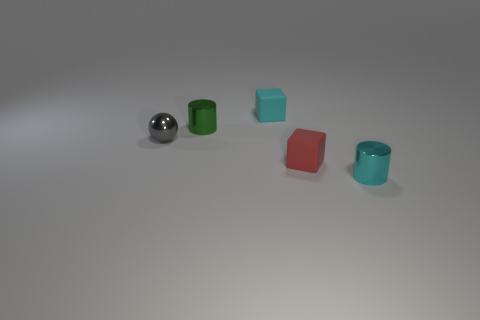How many tiny red things have the same shape as the cyan rubber thing?
Keep it short and to the point. 1. There is a cyan object in front of the green metallic object to the left of the cyan rubber cube; what size is it?
Offer a very short reply. Small. What material is the red cube that is the same size as the metal ball?
Provide a succinct answer. Rubber. Is there a cube that has the same material as the green cylinder?
Provide a short and direct response. No. There is a small cube to the right of the block behind the small metallic cylinder that is to the left of the small cyan shiny cylinder; what is its color?
Provide a succinct answer. Red. There is a matte block that is behind the tiny gray metal object; does it have the same color as the small metallic cylinder in front of the tiny green cylinder?
Provide a succinct answer. Yes. Is there anything else that has the same color as the small ball?
Your answer should be very brief. No. Is the number of red things that are left of the small cyan matte cube less than the number of big cylinders?
Your answer should be compact. No. What number of red metal cylinders are there?
Make the answer very short. 0. Does the cyan metal object have the same shape as the tiny rubber object that is behind the tiny green object?
Offer a terse response. No. 